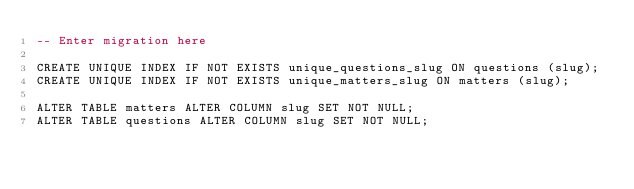<code> <loc_0><loc_0><loc_500><loc_500><_SQL_>-- Enter migration here

CREATE UNIQUE INDEX IF NOT EXISTS unique_questions_slug ON questions (slug);
CREATE UNIQUE INDEX IF NOT EXISTS unique_matters_slug ON matters (slug);

ALTER TABLE matters ALTER COLUMN slug SET NOT NULL;
ALTER TABLE questions ALTER COLUMN slug SET NOT NULL;
</code> 